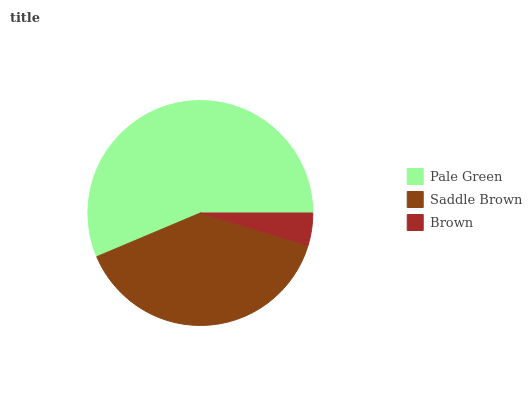Is Brown the minimum?
Answer yes or no. Yes. Is Pale Green the maximum?
Answer yes or no. Yes. Is Saddle Brown the minimum?
Answer yes or no. No. Is Saddle Brown the maximum?
Answer yes or no. No. Is Pale Green greater than Saddle Brown?
Answer yes or no. Yes. Is Saddle Brown less than Pale Green?
Answer yes or no. Yes. Is Saddle Brown greater than Pale Green?
Answer yes or no. No. Is Pale Green less than Saddle Brown?
Answer yes or no. No. Is Saddle Brown the high median?
Answer yes or no. Yes. Is Saddle Brown the low median?
Answer yes or no. Yes. Is Pale Green the high median?
Answer yes or no. No. Is Pale Green the low median?
Answer yes or no. No. 